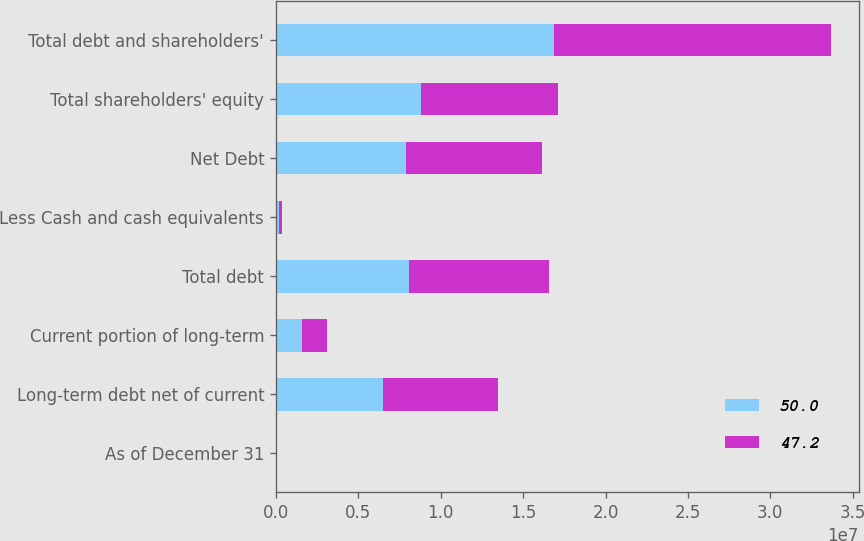Convert chart to OTSL. <chart><loc_0><loc_0><loc_500><loc_500><stacked_bar_chart><ecel><fcel>As of December 31<fcel>Long-term debt net of current<fcel>Current portion of long-term<fcel>Total debt<fcel>Less Cash and cash equivalents<fcel>Net Debt<fcel>Total shareholders' equity<fcel>Total debt and shareholders'<nl><fcel>50<fcel>2013<fcel>6.51143e+06<fcel>1.56338e+06<fcel>8.0748e+06<fcel>204687<fcel>7.87012e+06<fcel>8.80826e+06<fcel>1.68831e+07<nl><fcel>47.2<fcel>2012<fcel>6.97046e+06<fcel>1.51948e+06<fcel>8.48995e+06<fcel>194855<fcel>8.29509e+06<fcel>8.30875e+06<fcel>1.67987e+07<nl></chart> 